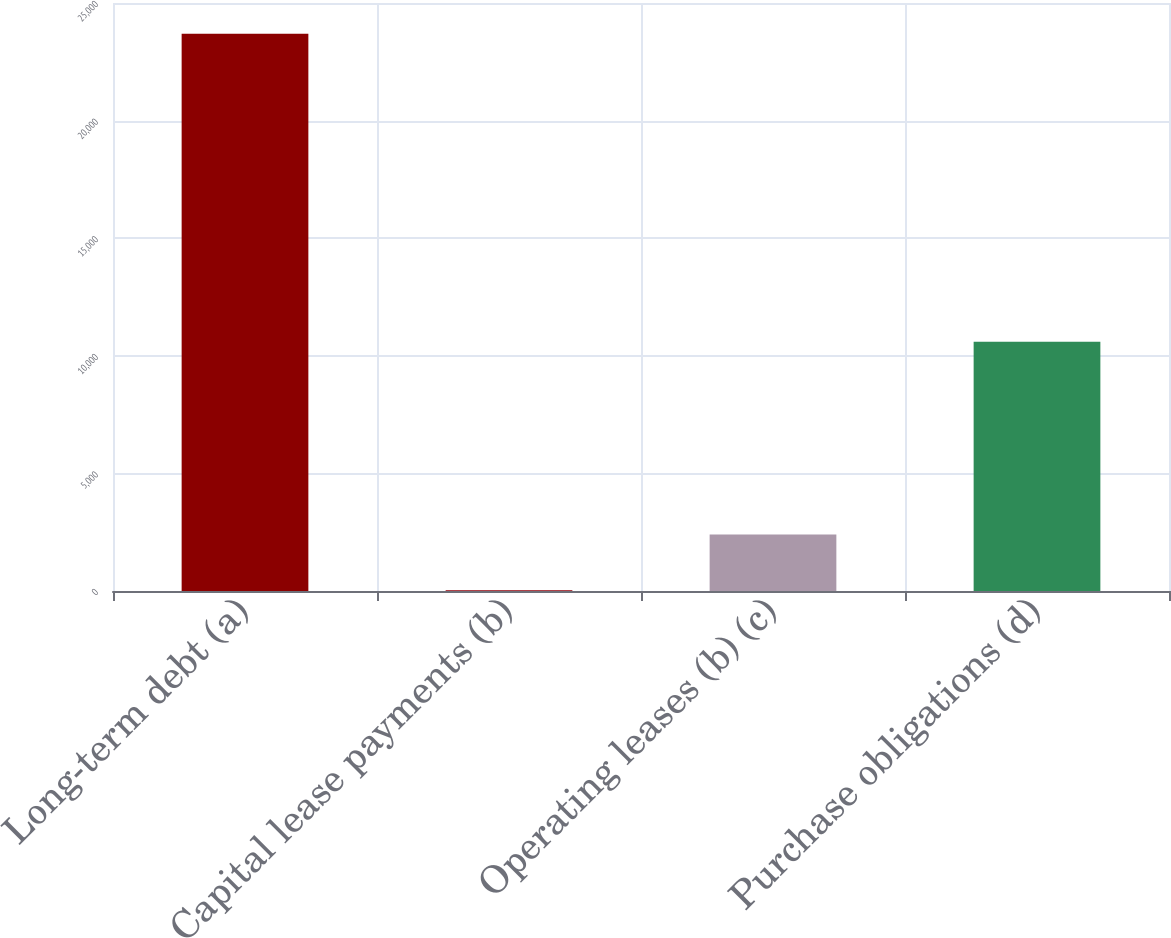Convert chart. <chart><loc_0><loc_0><loc_500><loc_500><bar_chart><fcel>Long-term debt (a)<fcel>Capital lease payments (b)<fcel>Operating leases (b) (c)<fcel>Purchase obligations (d)<nl><fcel>23689<fcel>34<fcel>2399.5<fcel>10599<nl></chart> 